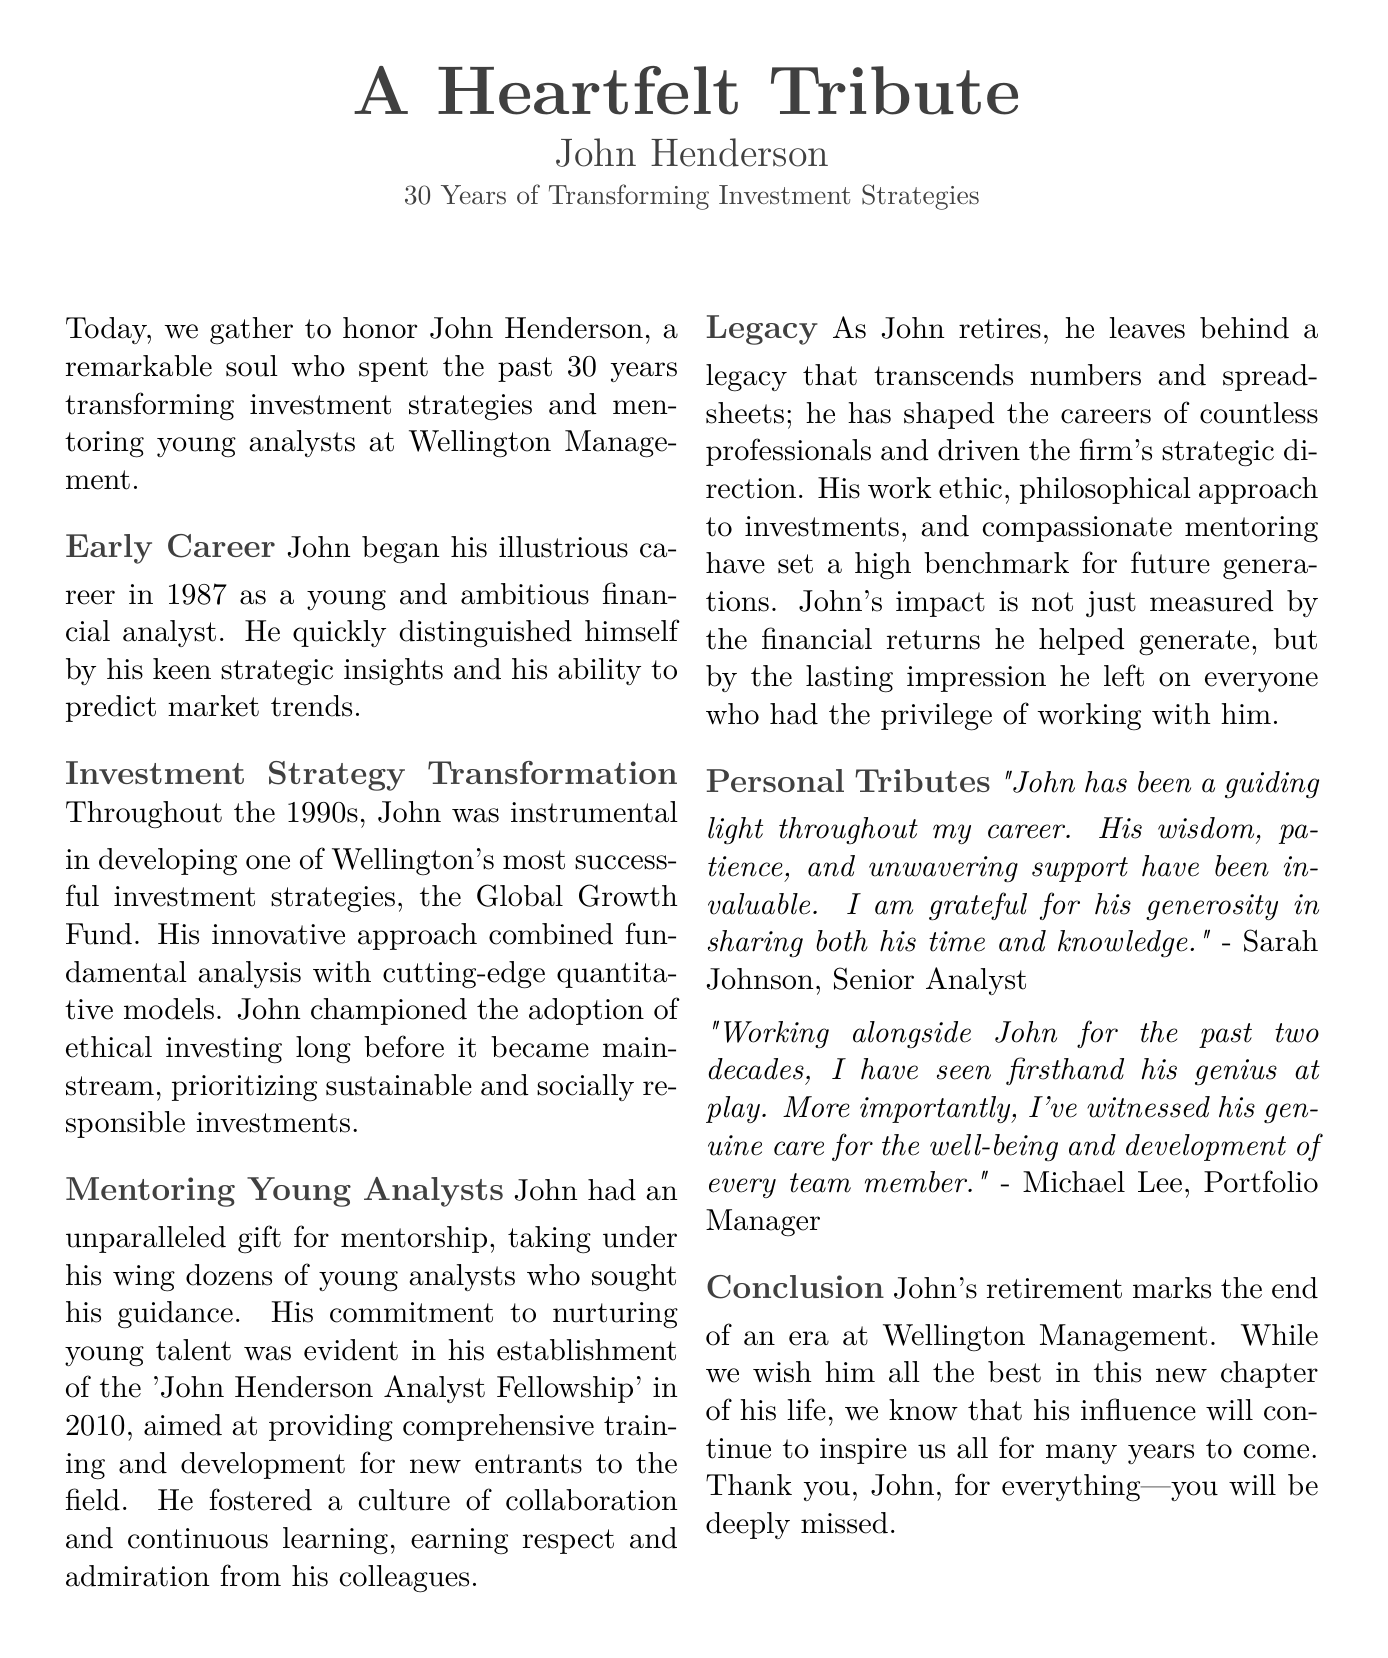what year did John begin his career? John began his illustrious career in 1987, as stated in the document.
Answer: 1987 what is the name of the fund John helped develop? The document mentions that John was instrumental in developing the Global Growth Fund.
Answer: Global Growth Fund when was the 'John Henderson Analyst Fellowship' established? According to the document, the fellowship was established in 2010.
Answer: 2010 what approach did John champion before it became mainstream? The document highlights that John championed the adoption of ethical investing long before it became mainstream.
Answer: Ethical investing who is the quote attributed to about John's mentorship? The document cites a quote by Sarah Johnson, Senior Analyst, regarding John's mentorship.
Answer: Sarah Johnson what characteristic is mentioned as John’s gift? The document describes John's unparalleled gift as mentorship.
Answer: Mentorship how long did John dedicate to Wellington Management? The document states that John dedicated 30 years to Wellington Management.
Answer: 30 years what values did John prioritize in his investment strategies? The document indicates that John prioritized sustainable and socially responsible investments.
Answer: Sustainable and socially responsible investments what did John's legacy impact beyond? The document mentions that John’s legacy transcends numbers and spreadsheets.
Answer: Numbers and spreadsheets 